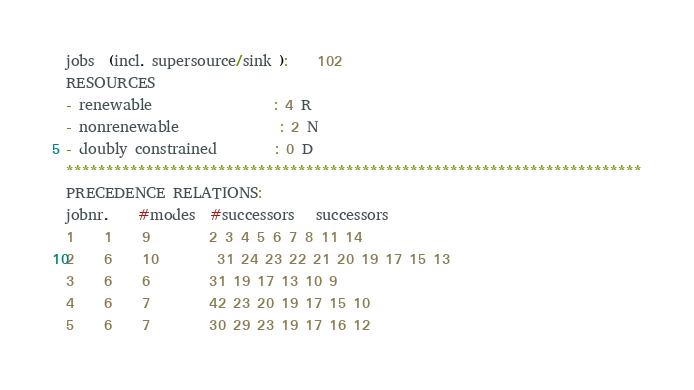<code> <loc_0><loc_0><loc_500><loc_500><_ObjectiveC_>jobs  (incl. supersource/sink ):	102
RESOURCES
- renewable                 : 4 R
- nonrenewable              : 2 N
- doubly constrained        : 0 D
************************************************************************
PRECEDENCE RELATIONS:
jobnr.    #modes  #successors   successors
1	1	9		2 3 4 5 6 7 8 11 14 
2	6	10		31 24 23 22 21 20 19 17 15 13 
3	6	6		31 19 17 13 10 9 
4	6	7		42 23 20 19 17 15 10 
5	6	7		30 29 23 19 17 16 12 </code> 